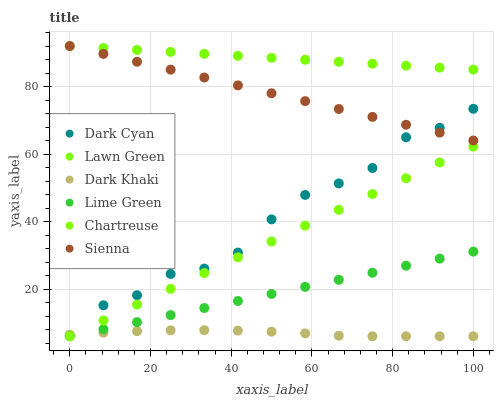Does Dark Khaki have the minimum area under the curve?
Answer yes or no. Yes. Does Lawn Green have the maximum area under the curve?
Answer yes or no. Yes. Does Sienna have the minimum area under the curve?
Answer yes or no. No. Does Sienna have the maximum area under the curve?
Answer yes or no. No. Is Sienna the smoothest?
Answer yes or no. Yes. Is Dark Cyan the roughest?
Answer yes or no. Yes. Is Dark Khaki the smoothest?
Answer yes or no. No. Is Dark Khaki the roughest?
Answer yes or no. No. Does Dark Khaki have the lowest value?
Answer yes or no. Yes. Does Sienna have the lowest value?
Answer yes or no. No. Does Sienna have the highest value?
Answer yes or no. Yes. Does Dark Khaki have the highest value?
Answer yes or no. No. Is Dark Khaki less than Sienna?
Answer yes or no. Yes. Is Lawn Green greater than Dark Cyan?
Answer yes or no. Yes. Does Lime Green intersect Dark Khaki?
Answer yes or no. Yes. Is Lime Green less than Dark Khaki?
Answer yes or no. No. Is Lime Green greater than Dark Khaki?
Answer yes or no. No. Does Dark Khaki intersect Sienna?
Answer yes or no. No. 